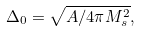<formula> <loc_0><loc_0><loc_500><loc_500>\Delta _ { 0 } = \sqrt { A / 4 \pi M _ { s } ^ { 2 } } ,</formula> 